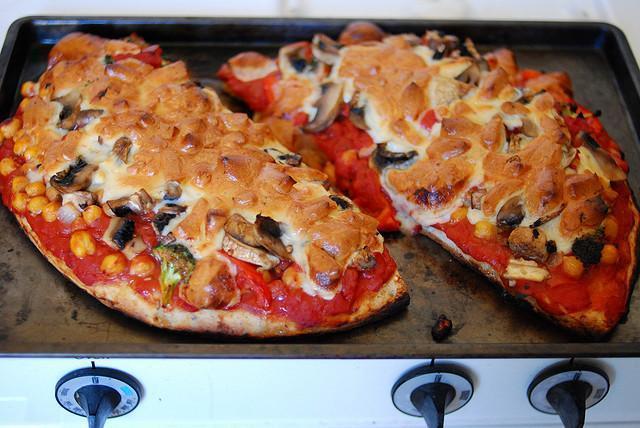Is the given caption "The broccoli is on the oven." fitting for the image?
Answer yes or no. No. 